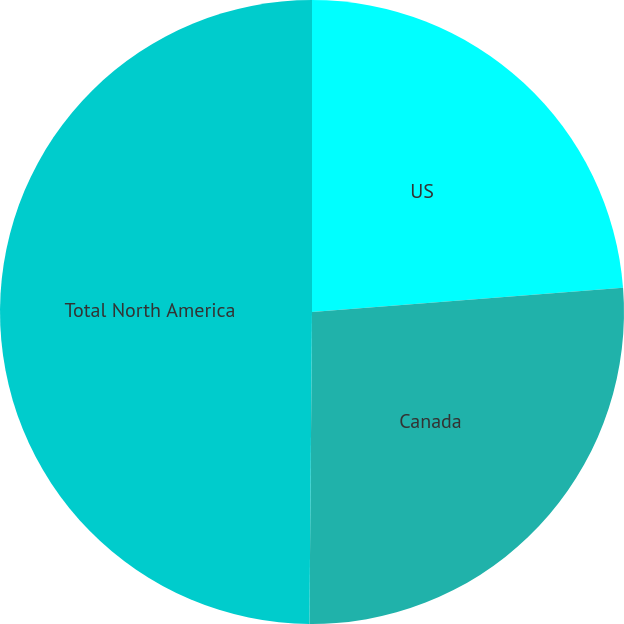Convert chart to OTSL. <chart><loc_0><loc_0><loc_500><loc_500><pie_chart><fcel>US<fcel>Canada<fcel>Total North America<nl><fcel>23.76%<fcel>26.37%<fcel>49.87%<nl></chart> 